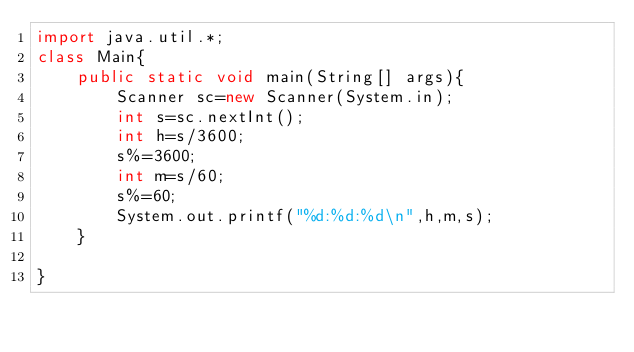<code> <loc_0><loc_0><loc_500><loc_500><_Java_>import java.util.*;
class Main{
    public static void main(String[] args){
        Scanner sc=new Scanner(System.in);
        int s=sc.nextInt();
        int h=s/3600;
        s%=3600;
        int m=s/60;
        s%=60;
        System.out.printf("%d:%d:%d\n",h,m,s);
    }

}</code> 